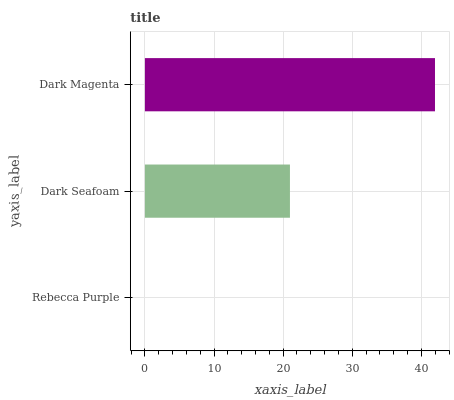Is Rebecca Purple the minimum?
Answer yes or no. Yes. Is Dark Magenta the maximum?
Answer yes or no. Yes. Is Dark Seafoam the minimum?
Answer yes or no. No. Is Dark Seafoam the maximum?
Answer yes or no. No. Is Dark Seafoam greater than Rebecca Purple?
Answer yes or no. Yes. Is Rebecca Purple less than Dark Seafoam?
Answer yes or no. Yes. Is Rebecca Purple greater than Dark Seafoam?
Answer yes or no. No. Is Dark Seafoam less than Rebecca Purple?
Answer yes or no. No. Is Dark Seafoam the high median?
Answer yes or no. Yes. Is Dark Seafoam the low median?
Answer yes or no. Yes. Is Dark Magenta the high median?
Answer yes or no. No. Is Rebecca Purple the low median?
Answer yes or no. No. 